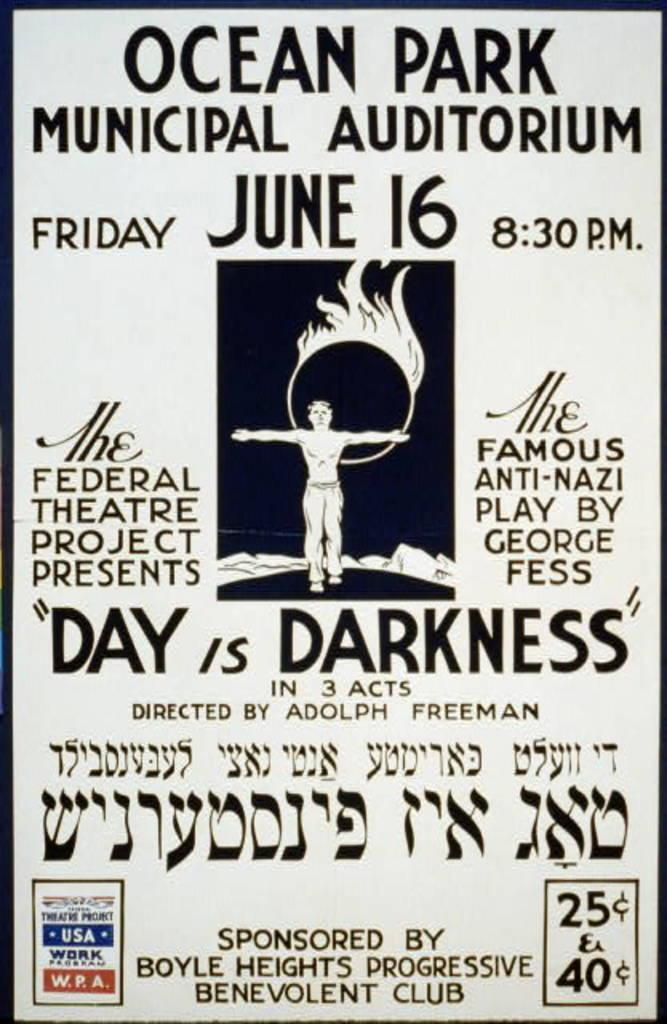<image>
Create a compact narrative representing the image presented. A vintage poster for an anti-Nazi play taking place on June 16 